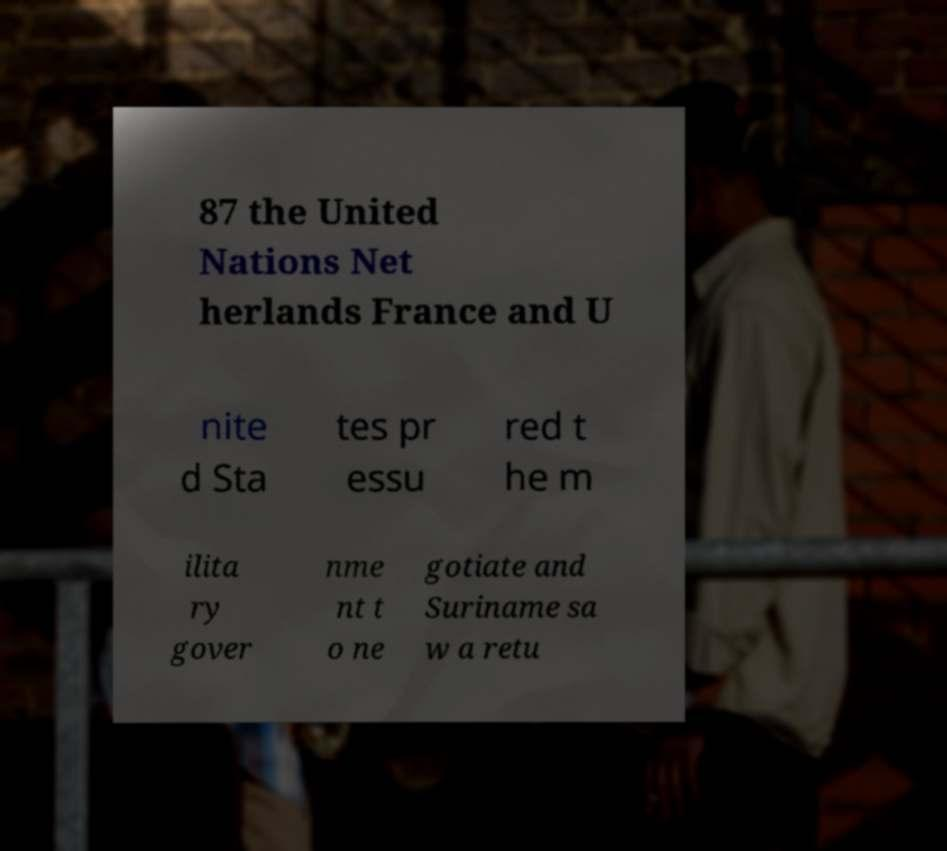Can you read and provide the text displayed in the image?This photo seems to have some interesting text. Can you extract and type it out for me? 87 the United Nations Net herlands France and U nite d Sta tes pr essu red t he m ilita ry gover nme nt t o ne gotiate and Suriname sa w a retu 